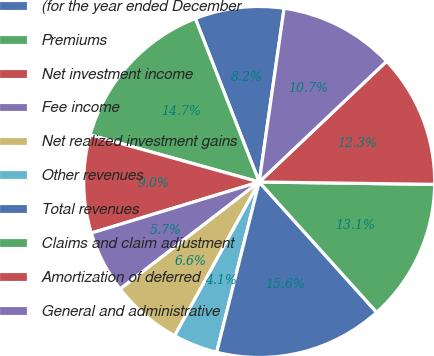Convert chart to OTSL. <chart><loc_0><loc_0><loc_500><loc_500><pie_chart><fcel>(for the year ended December<fcel>Premiums<fcel>Net investment income<fcel>Fee income<fcel>Net realized investment gains<fcel>Other revenues<fcel>Total revenues<fcel>Claims and claim adjustment<fcel>Amortization of deferred<fcel>General and administrative<nl><fcel>8.2%<fcel>14.75%<fcel>9.02%<fcel>5.74%<fcel>6.56%<fcel>4.1%<fcel>15.57%<fcel>13.11%<fcel>12.29%<fcel>10.66%<nl></chart> 